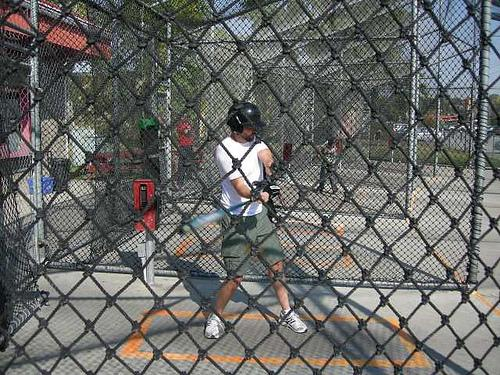What is the man standing in?

Choices:
A) school yard
B) batting cage
C) prison cell
D) backyard batting cage 